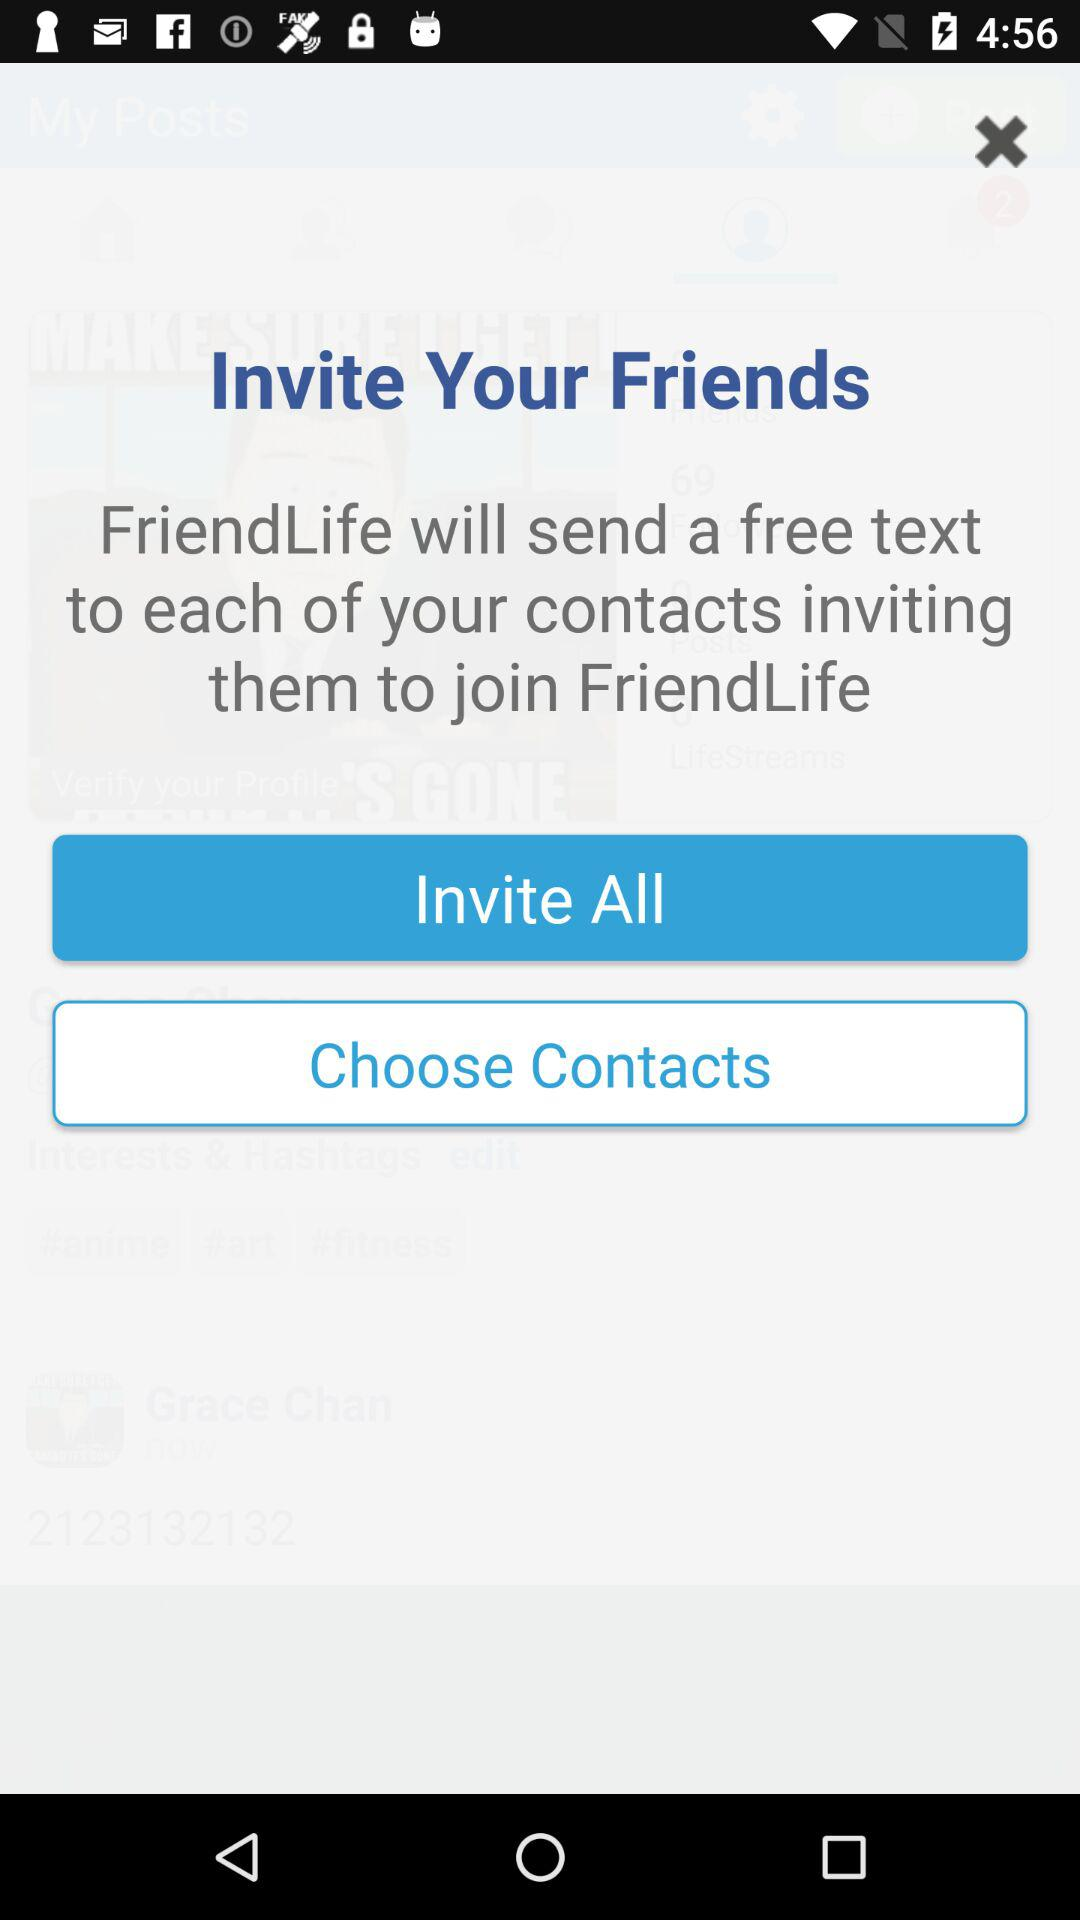What is the app title? The app title is "FriendLife". 